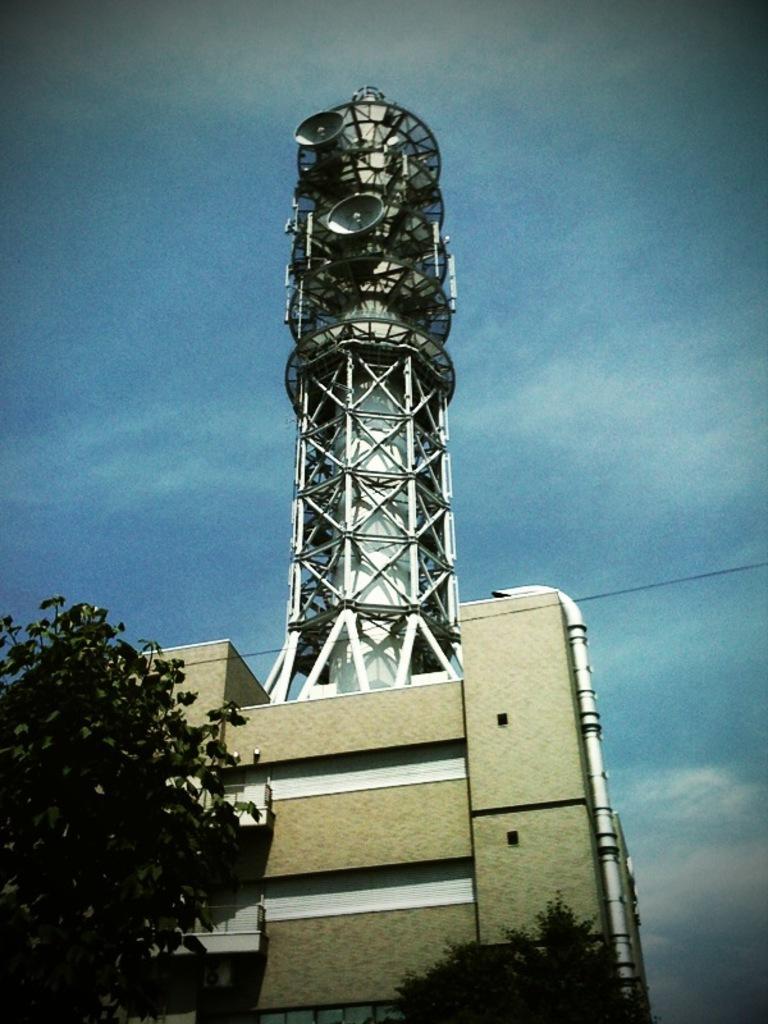In one or two sentences, can you explain what this image depicts? In this image we can see trees, building, tower, pipe, wire and the blue color sky in the background. 